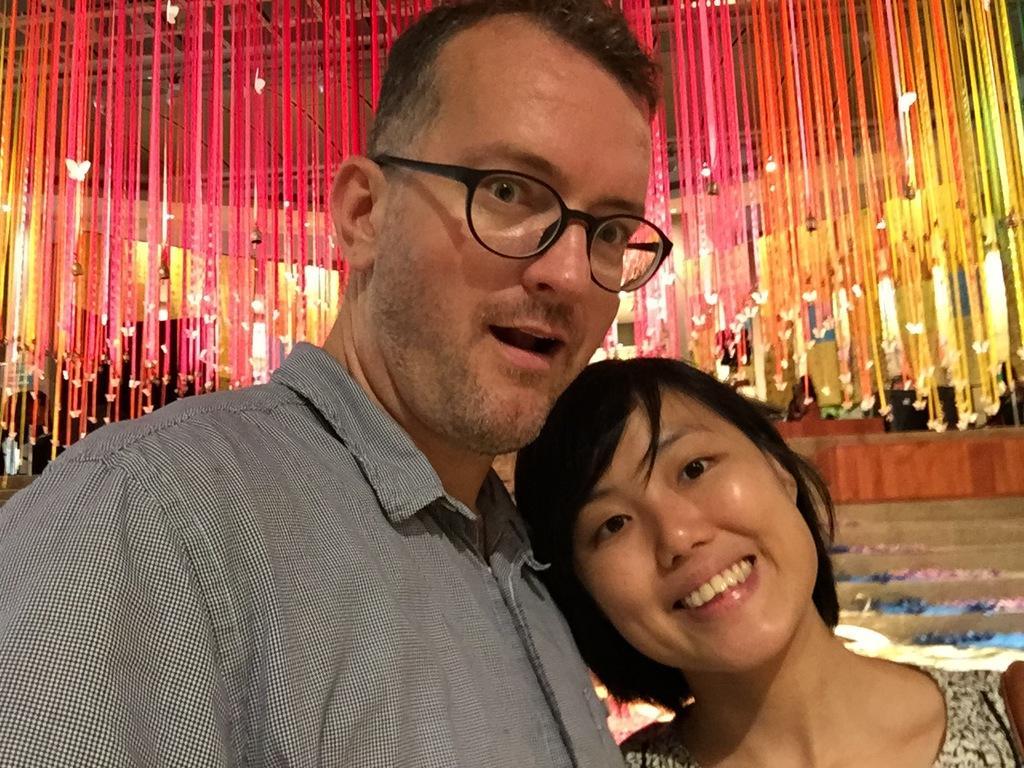In one or two sentences, can you explain what this image depicts? In this image we can see a man and a woman standing and in the background there are stairs and some decorative items hanged to the ceiling. 